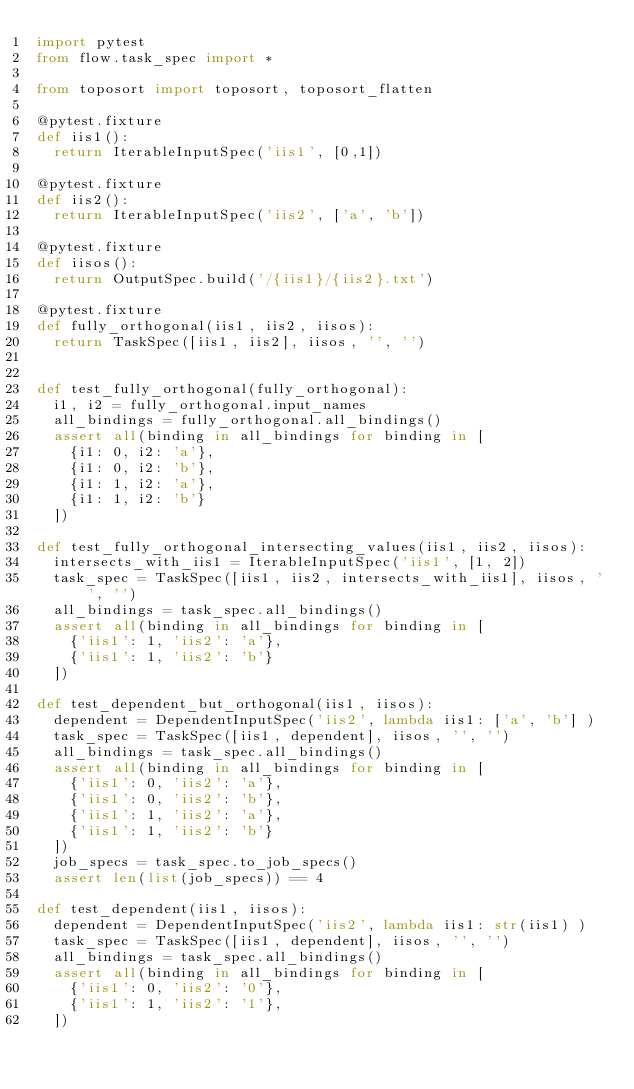Convert code to text. <code><loc_0><loc_0><loc_500><loc_500><_Python_>import pytest
from flow.task_spec import *

from toposort import toposort, toposort_flatten

@pytest.fixture
def iis1():
  return IterableInputSpec('iis1', [0,1])

@pytest.fixture
def iis2():
  return IterableInputSpec('iis2', ['a', 'b'])

@pytest.fixture
def iisos():
  return OutputSpec.build('/{iis1}/{iis2}.txt')

@pytest.fixture
def fully_orthogonal(iis1, iis2, iisos):
  return TaskSpec([iis1, iis2], iisos, '', '')


def test_fully_orthogonal(fully_orthogonal):
  i1, i2 = fully_orthogonal.input_names
  all_bindings = fully_orthogonal.all_bindings()
  assert all(binding in all_bindings for binding in [
    {i1: 0, i2: 'a'},
    {i1: 0, i2: 'b'},
    {i1: 1, i2: 'a'},
    {i1: 1, i2: 'b'}
  ])

def test_fully_orthogonal_intersecting_values(iis1, iis2, iisos):
  intersects_with_iis1 = IterableInputSpec('iis1', [1, 2])
  task_spec = TaskSpec([iis1, iis2, intersects_with_iis1], iisos, '', '')
  all_bindings = task_spec.all_bindings()
  assert all(binding in all_bindings for binding in [
    {'iis1': 1, 'iis2': 'a'},
    {'iis1': 1, 'iis2': 'b'}
  ])

def test_dependent_but_orthogonal(iis1, iisos):
  dependent = DependentInputSpec('iis2', lambda iis1: ['a', 'b'] )
  task_spec = TaskSpec([iis1, dependent], iisos, '', '')
  all_bindings = task_spec.all_bindings()
  assert all(binding in all_bindings for binding in [
    {'iis1': 0, 'iis2': 'a'},
    {'iis1': 0, 'iis2': 'b'},
    {'iis1': 1, 'iis2': 'a'},
    {'iis1': 1, 'iis2': 'b'}
  ])
  job_specs = task_spec.to_job_specs()
  assert len(list(job_specs)) == 4

def test_dependent(iis1, iisos):
  dependent = DependentInputSpec('iis2', lambda iis1: str(iis1) )
  task_spec = TaskSpec([iis1, dependent], iisos, '', '')
  all_bindings = task_spec.all_bindings()
  assert all(binding in all_bindings for binding in [
    {'iis1': 0, 'iis2': '0'},
    {'iis1': 1, 'iis2': '1'},
  ])
</code> 